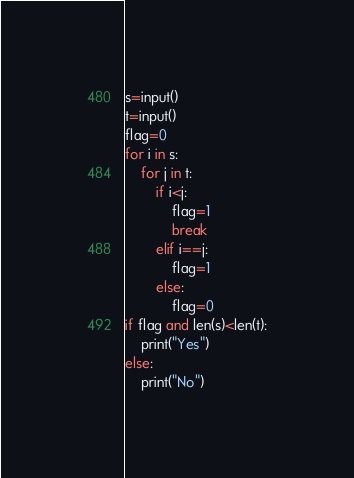Convert code to text. <code><loc_0><loc_0><loc_500><loc_500><_Python_>s=input()
t=input()
flag=0
for i in s:
    for j in t:
        if i<j:
            flag=1
            break
        elif i==j:
            flag=1
        else:
            flag=0
if flag and len(s)<len(t):
    print("Yes")
else:
    print("No")
</code> 